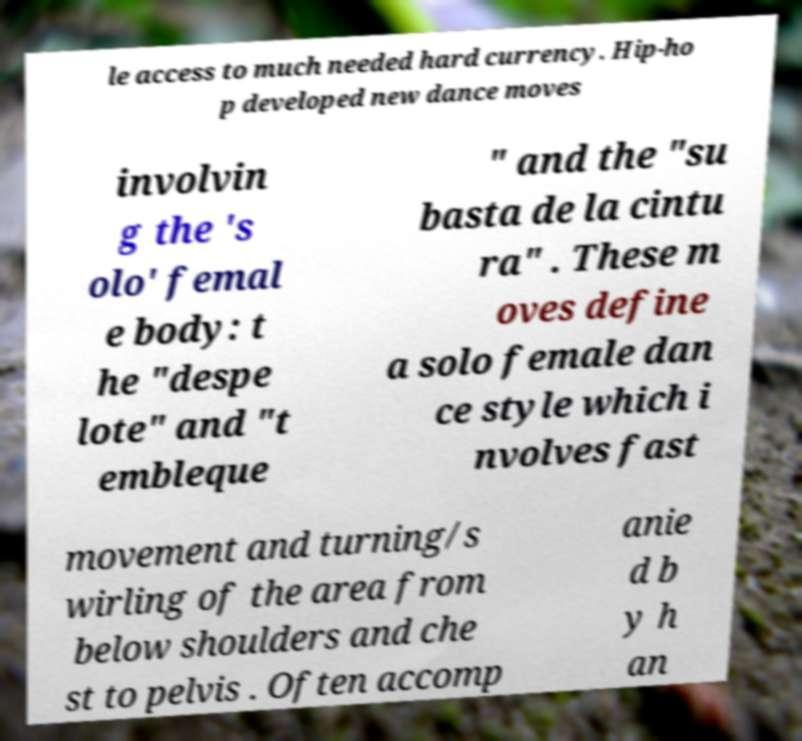Please identify and transcribe the text found in this image. le access to much needed hard currency. Hip-ho p developed new dance moves involvin g the 's olo' femal e body: t he "despe lote" and "t embleque " and the "su basta de la cintu ra" . These m oves define a solo female dan ce style which i nvolves fast movement and turning/s wirling of the area from below shoulders and che st to pelvis . Often accomp anie d b y h an 